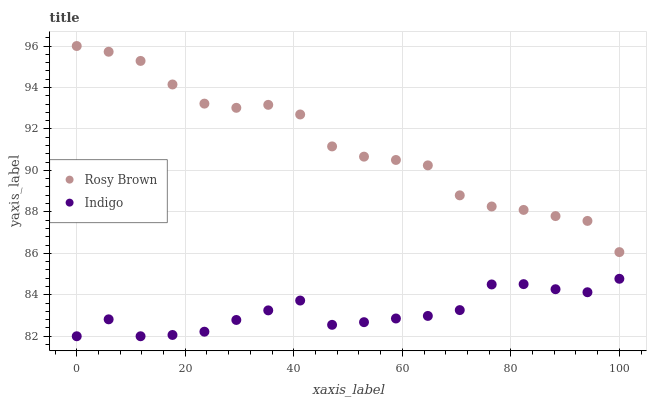Does Indigo have the minimum area under the curve?
Answer yes or no. Yes. Does Rosy Brown have the maximum area under the curve?
Answer yes or no. Yes. Does Indigo have the maximum area under the curve?
Answer yes or no. No. Is Rosy Brown the smoothest?
Answer yes or no. Yes. Is Indigo the roughest?
Answer yes or no. Yes. Is Indigo the smoothest?
Answer yes or no. No. Does Indigo have the lowest value?
Answer yes or no. Yes. Does Rosy Brown have the highest value?
Answer yes or no. Yes. Does Indigo have the highest value?
Answer yes or no. No. Is Indigo less than Rosy Brown?
Answer yes or no. Yes. Is Rosy Brown greater than Indigo?
Answer yes or no. Yes. Does Indigo intersect Rosy Brown?
Answer yes or no. No. 